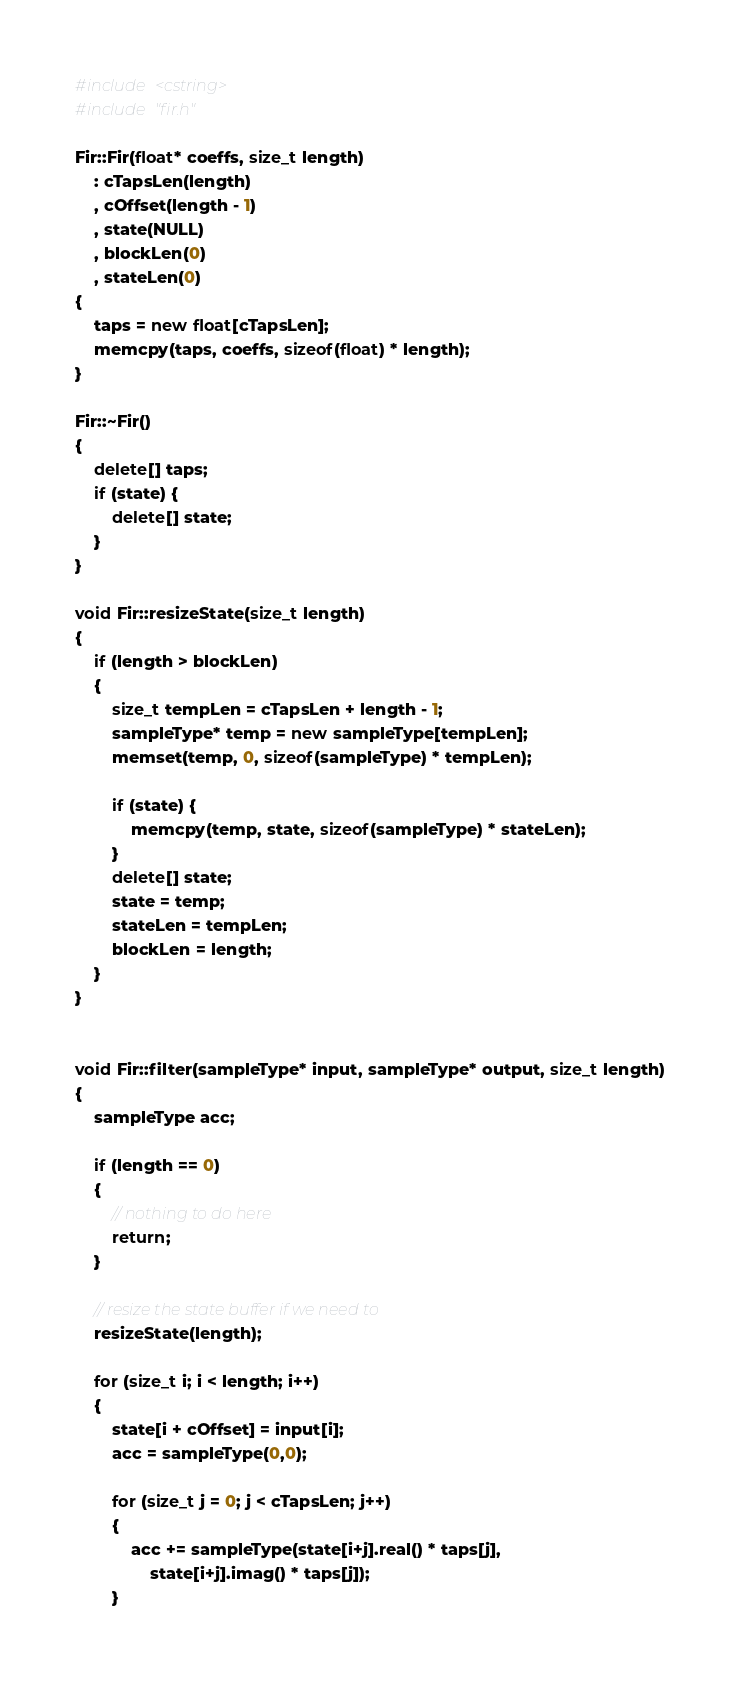Convert code to text. <code><loc_0><loc_0><loc_500><loc_500><_C++_>#include <cstring>
#include "fir.h"

Fir::Fir(float* coeffs, size_t length)
	: cTapsLen(length)
	, cOffset(length - 1)
	, state(NULL)
	, blockLen(0)
	, stateLen(0)
{
	taps = new float[cTapsLen];
	memcpy(taps, coeffs, sizeof(float) * length);
}

Fir::~Fir()
{
	delete[] taps;
	if (state) {
		delete[] state;
	}
}

void Fir::resizeState(size_t length)
{
	if (length > blockLen)
	{
		size_t tempLen = cTapsLen + length - 1;
		sampleType* temp = new sampleType[tempLen];
		memset(temp, 0, sizeof(sampleType) * tempLen);

		if (state) {
			memcpy(temp, state, sizeof(sampleType) * stateLen);
		}
		delete[] state;
		state = temp;
		stateLen = tempLen;
		blockLen = length;
	}
}


void Fir::filter(sampleType* input, sampleType* output, size_t length)
{
	sampleType acc;
	
	if (length == 0) 
	{
		// nothing to do here
		return;
	}

	// resize the state buffer if we need to
	resizeState(length);

	for (size_t i; i < length; i++)
	{
		state[i + cOffset] = input[i];
		acc = sampleType(0,0);

		for (size_t j = 0; j < cTapsLen; j++)
		{
			acc += sampleType(state[i+j].real() * taps[j], 
				state[i+j].imag() * taps[j]);
		}</code> 